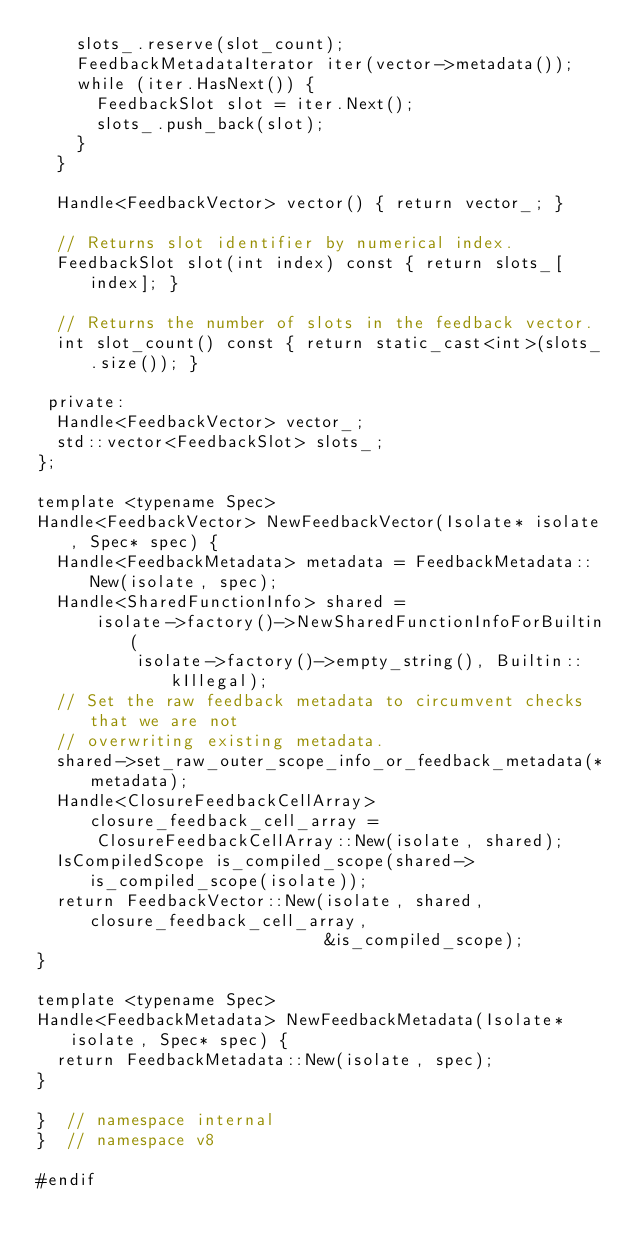<code> <loc_0><loc_0><loc_500><loc_500><_C_>    slots_.reserve(slot_count);
    FeedbackMetadataIterator iter(vector->metadata());
    while (iter.HasNext()) {
      FeedbackSlot slot = iter.Next();
      slots_.push_back(slot);
    }
  }

  Handle<FeedbackVector> vector() { return vector_; }

  // Returns slot identifier by numerical index.
  FeedbackSlot slot(int index) const { return slots_[index]; }

  // Returns the number of slots in the feedback vector.
  int slot_count() const { return static_cast<int>(slots_.size()); }

 private:
  Handle<FeedbackVector> vector_;
  std::vector<FeedbackSlot> slots_;
};

template <typename Spec>
Handle<FeedbackVector> NewFeedbackVector(Isolate* isolate, Spec* spec) {
  Handle<FeedbackMetadata> metadata = FeedbackMetadata::New(isolate, spec);
  Handle<SharedFunctionInfo> shared =
      isolate->factory()->NewSharedFunctionInfoForBuiltin(
          isolate->factory()->empty_string(), Builtin::kIllegal);
  // Set the raw feedback metadata to circumvent checks that we are not
  // overwriting existing metadata.
  shared->set_raw_outer_scope_info_or_feedback_metadata(*metadata);
  Handle<ClosureFeedbackCellArray> closure_feedback_cell_array =
      ClosureFeedbackCellArray::New(isolate, shared);
  IsCompiledScope is_compiled_scope(shared->is_compiled_scope(isolate));
  return FeedbackVector::New(isolate, shared, closure_feedback_cell_array,
                             &is_compiled_scope);
}

template <typename Spec>
Handle<FeedbackMetadata> NewFeedbackMetadata(Isolate* isolate, Spec* spec) {
  return FeedbackMetadata::New(isolate, spec);
}

}  // namespace internal
}  // namespace v8

#endif
</code> 